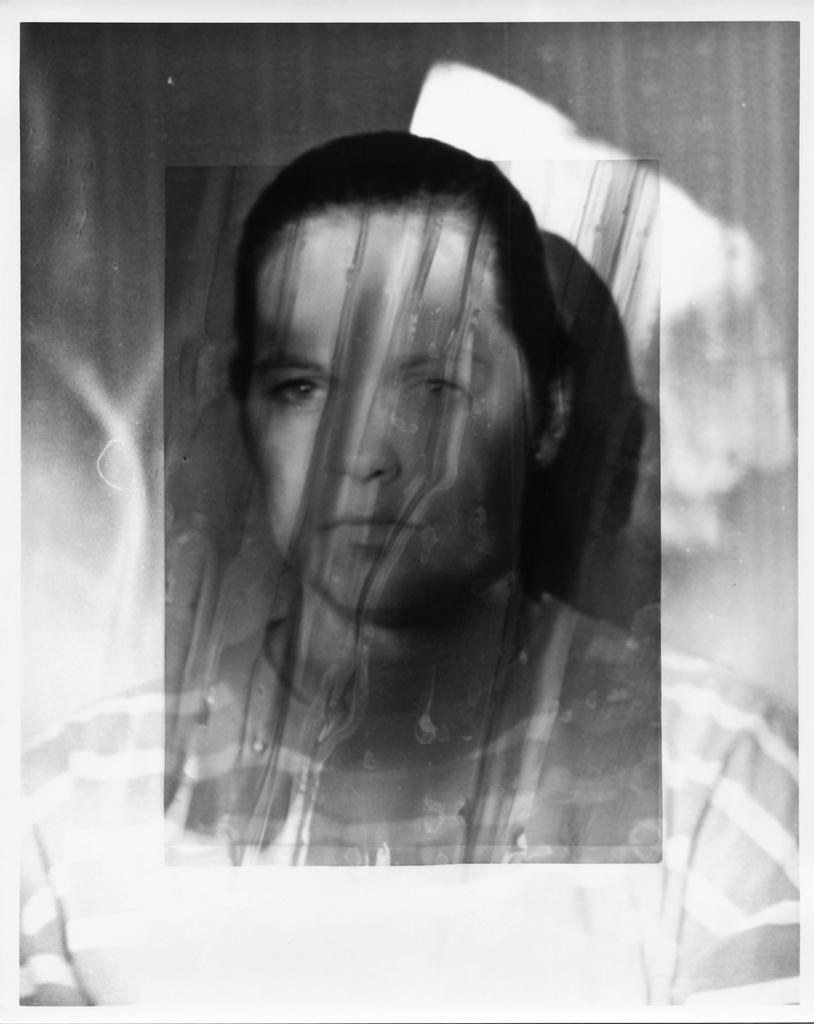What is the main subject in the foreground of the image? There is a woman in the foreground of the image. What is the color scheme of the image? The image is black and white. What type of liquid can be seen flowing through the wire in the image? There is no liquid or wire present in the image; it features a woman in the foreground and is black and white. 